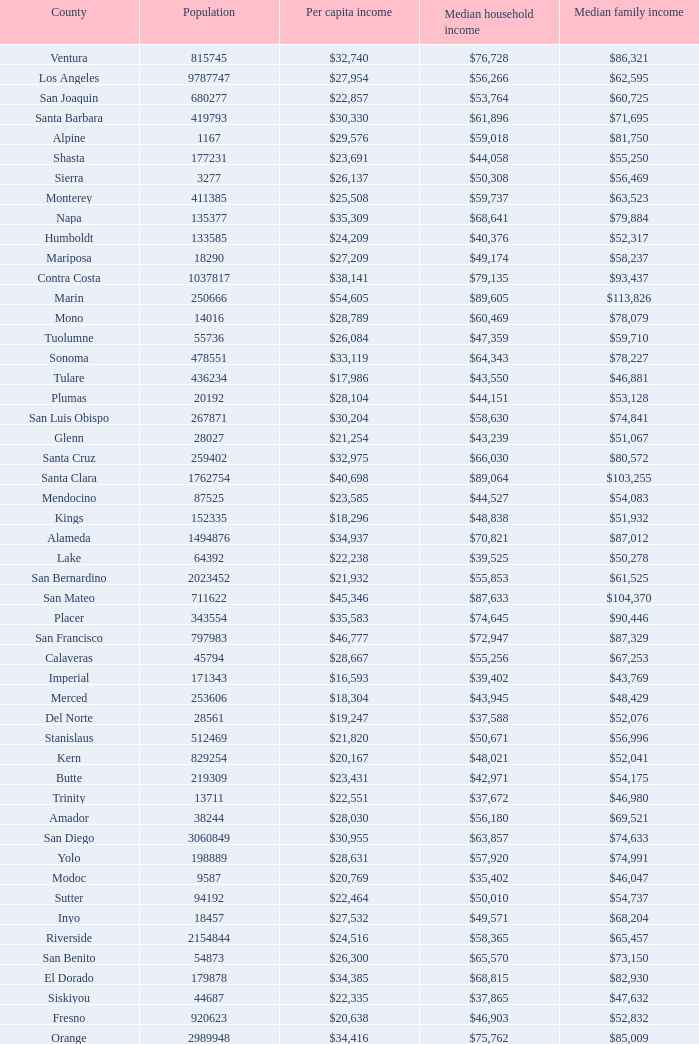What is the median household income of butte? $42,971. 